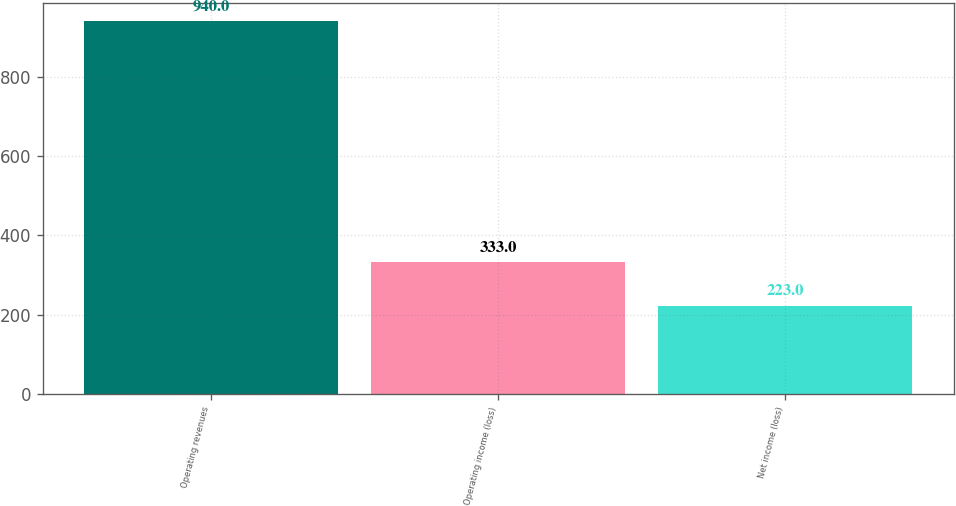Convert chart to OTSL. <chart><loc_0><loc_0><loc_500><loc_500><bar_chart><fcel>Operating revenues<fcel>Operating income (loss)<fcel>Net income (loss)<nl><fcel>940<fcel>333<fcel>223<nl></chart> 